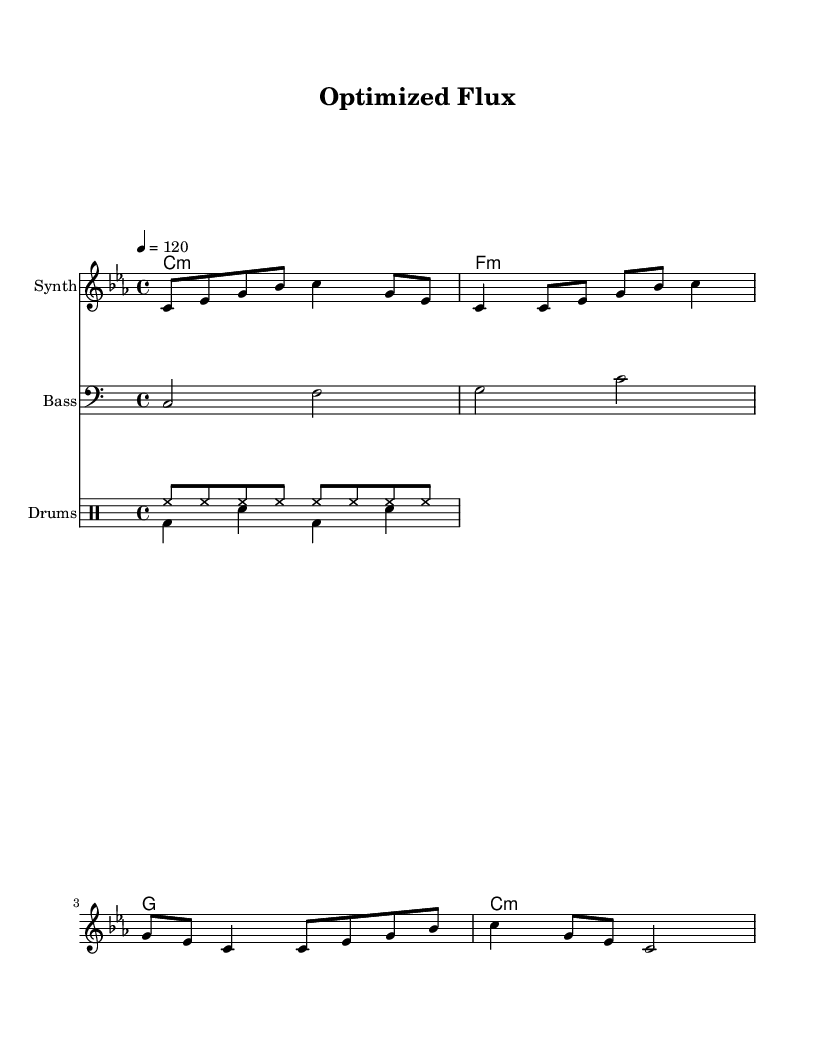What is the key signature of this music? The key signature is C minor, which has three flats (B flat, E flat, and A flat). This is indicated by the 'c' at the beginning of the staff, noting the minor key.
Answer: C minor What is the time signature of this music? The time signature is 4/4, which indicates that there are four beats in each measure and a quarter note receives one beat. This is shown at the beginning of the piece next to the key signature.
Answer: 4/4 What is the tempo marking for this piece? The tempo marking is 120 beats per minute, indicated by the text "4 = 120" at the start, which informs performers about the speed of the piece.
Answer: 120 How many sections are in the harmonic progression? The harmonic progression contains four sections (or chords): C minor, F minor, G major, and C minor again. These sections create a loop that repeats throughout the piece.
Answer: Four What type of instruments are used in this composition? The composition uses a synthesizer for the melody, a bass for the bassline, and drums for percussion. The instrument names are labeled at the beginning of each staff, making it clear which instruments are part of the score.
Answer: Synth, Bass, Drums What rhythmic pattern is predominant in the drum section? The predominant rhythmic pattern in the drum section includes a combination of hi-hats playing in eighth notes and a bass drum/snare combination in quarter notes. These patterns create a consistent but varied rhythmic foundation within the piece.
Answer: Hi-hat and bass/snare pattern What characteristic of the melody suggests an experimental style? The melody's use of syncopation and frequent changes in pitch and rhythm indicates a more avant-garde or experimental approach, as it deviates from traditional melodic structures, presenting an unpredictability that is typical for the genre.
Answer: Syncopation and unpredictability 